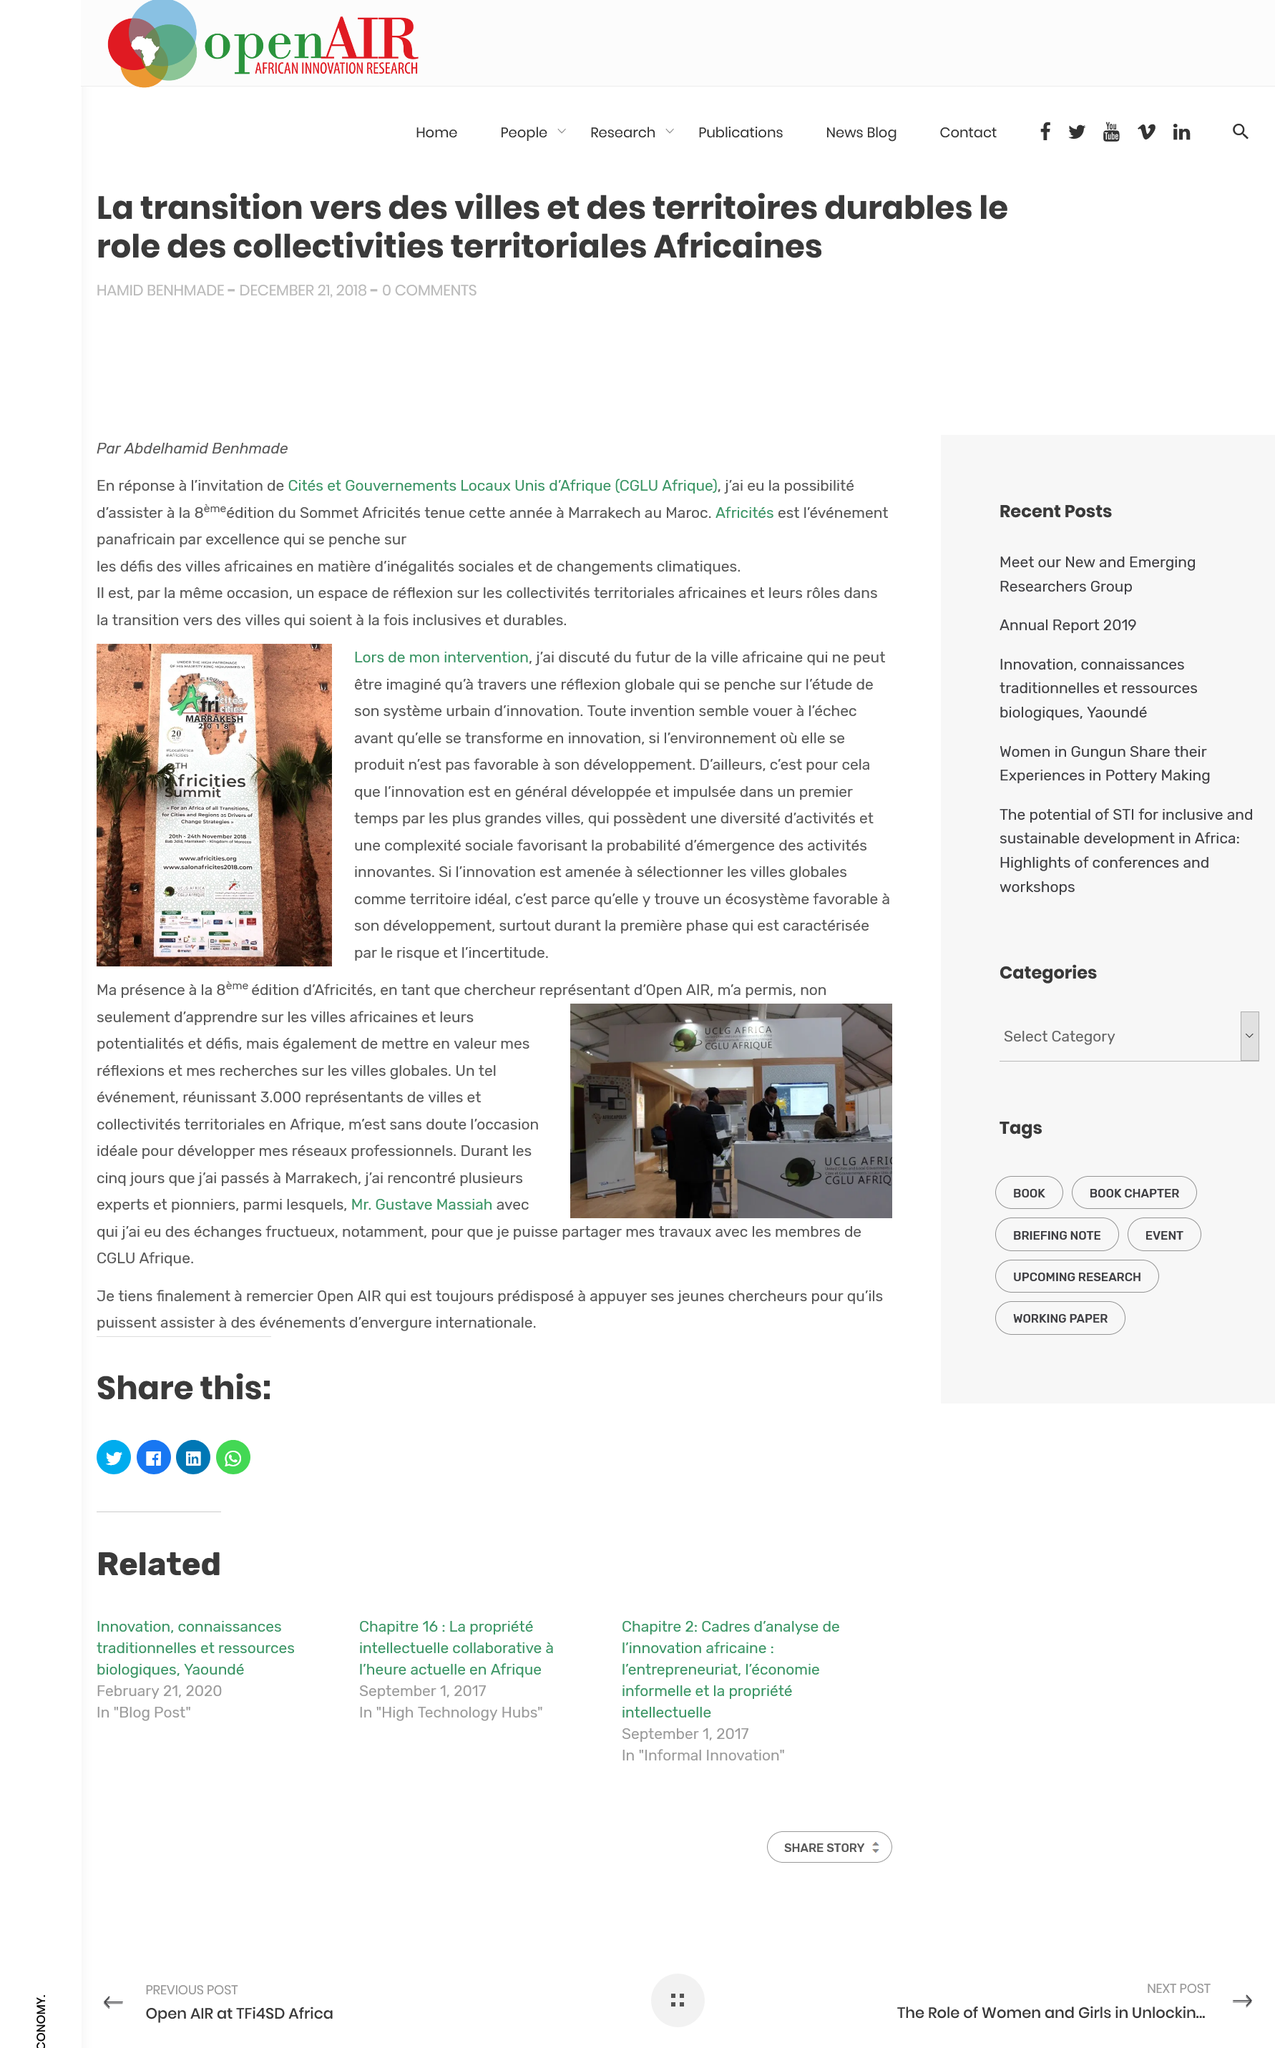Mention a couple of crucial points in this snapshot. Afrique is the French word for Africa, and the English translation of Afrique is Africa. There have been eight editions of the CGLU Afrique. At the event, there were three thousand representatives present. 